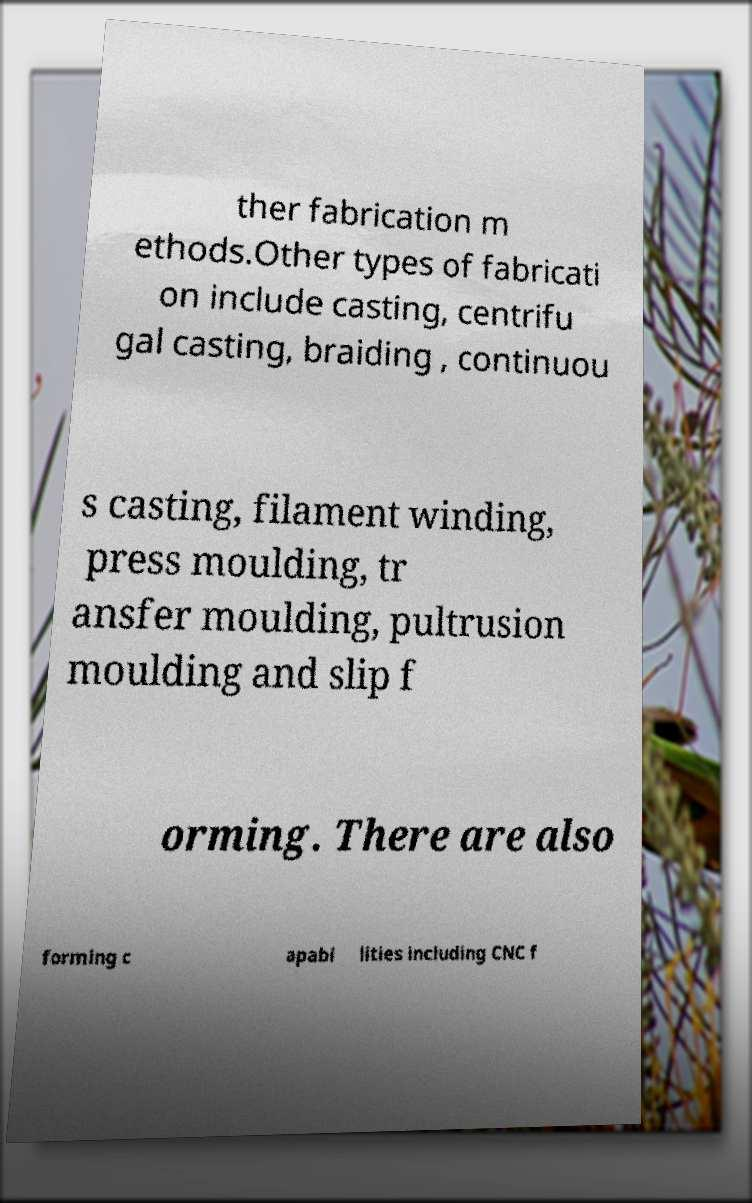Can you read and provide the text displayed in the image?This photo seems to have some interesting text. Can you extract and type it out for me? ther fabrication m ethods.Other types of fabricati on include casting, centrifu gal casting, braiding , continuou s casting, filament winding, press moulding, tr ansfer moulding, pultrusion moulding and slip f orming. There are also forming c apabi lities including CNC f 